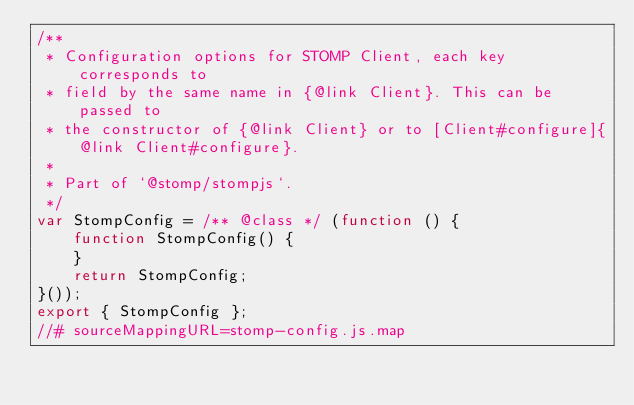<code> <loc_0><loc_0><loc_500><loc_500><_JavaScript_>/**
 * Configuration options for STOMP Client, each key corresponds to
 * field by the same name in {@link Client}. This can be passed to
 * the constructor of {@link Client} or to [Client#configure]{@link Client#configure}.
 *
 * Part of `@stomp/stompjs`.
 */
var StompConfig = /** @class */ (function () {
    function StompConfig() {
    }
    return StompConfig;
}());
export { StompConfig };
//# sourceMappingURL=stomp-config.js.map</code> 